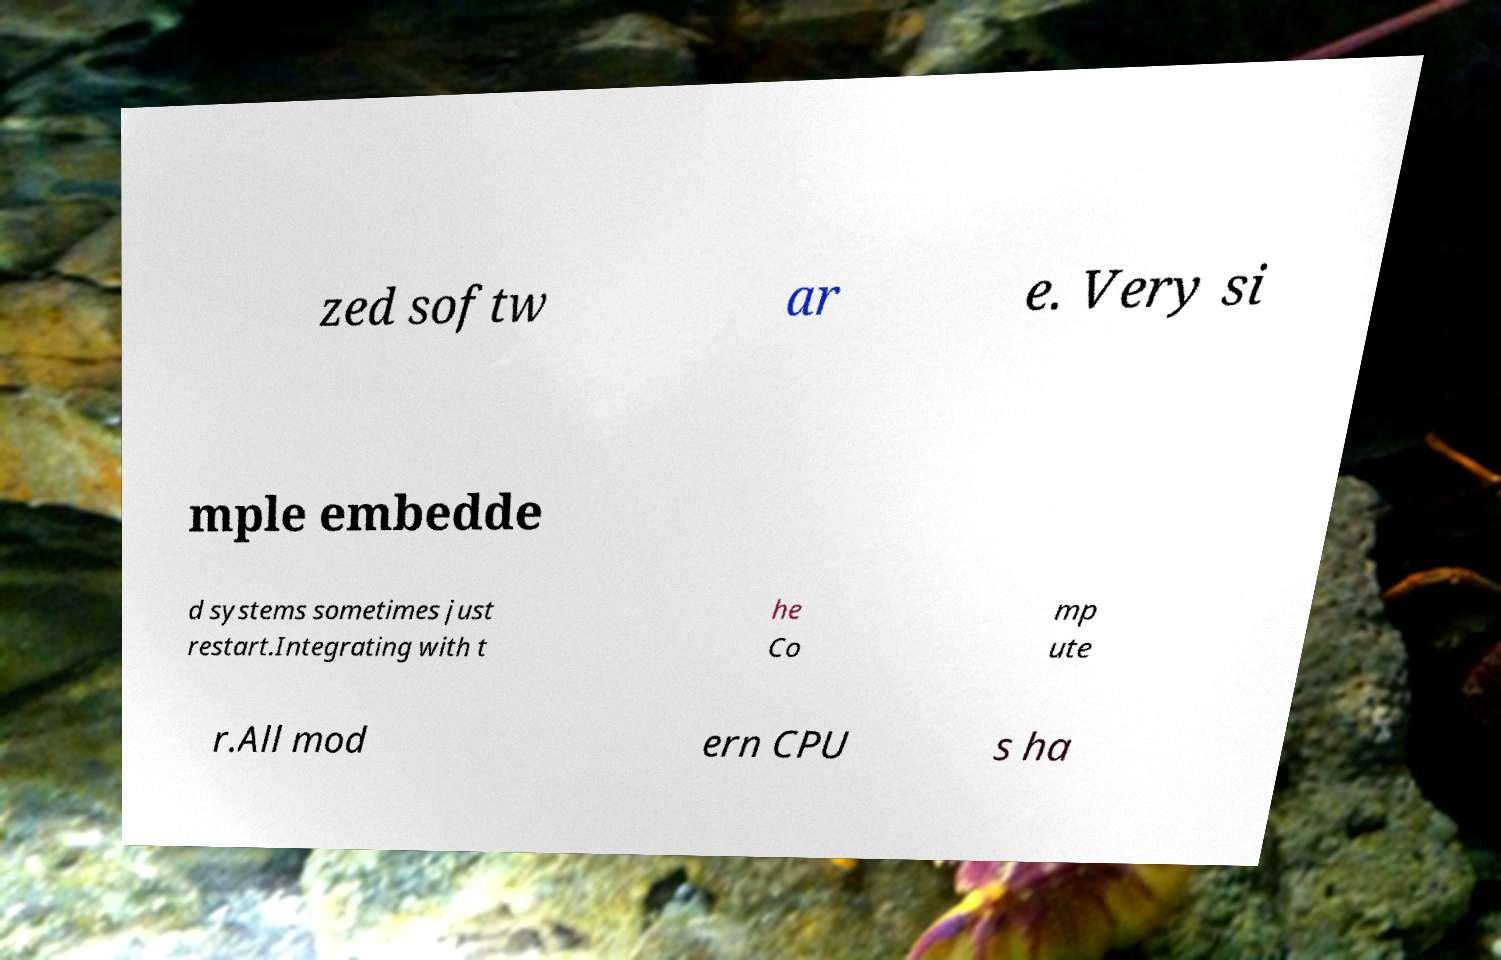What messages or text are displayed in this image? I need them in a readable, typed format. zed softw ar e. Very si mple embedde d systems sometimes just restart.Integrating with t he Co mp ute r.All mod ern CPU s ha 